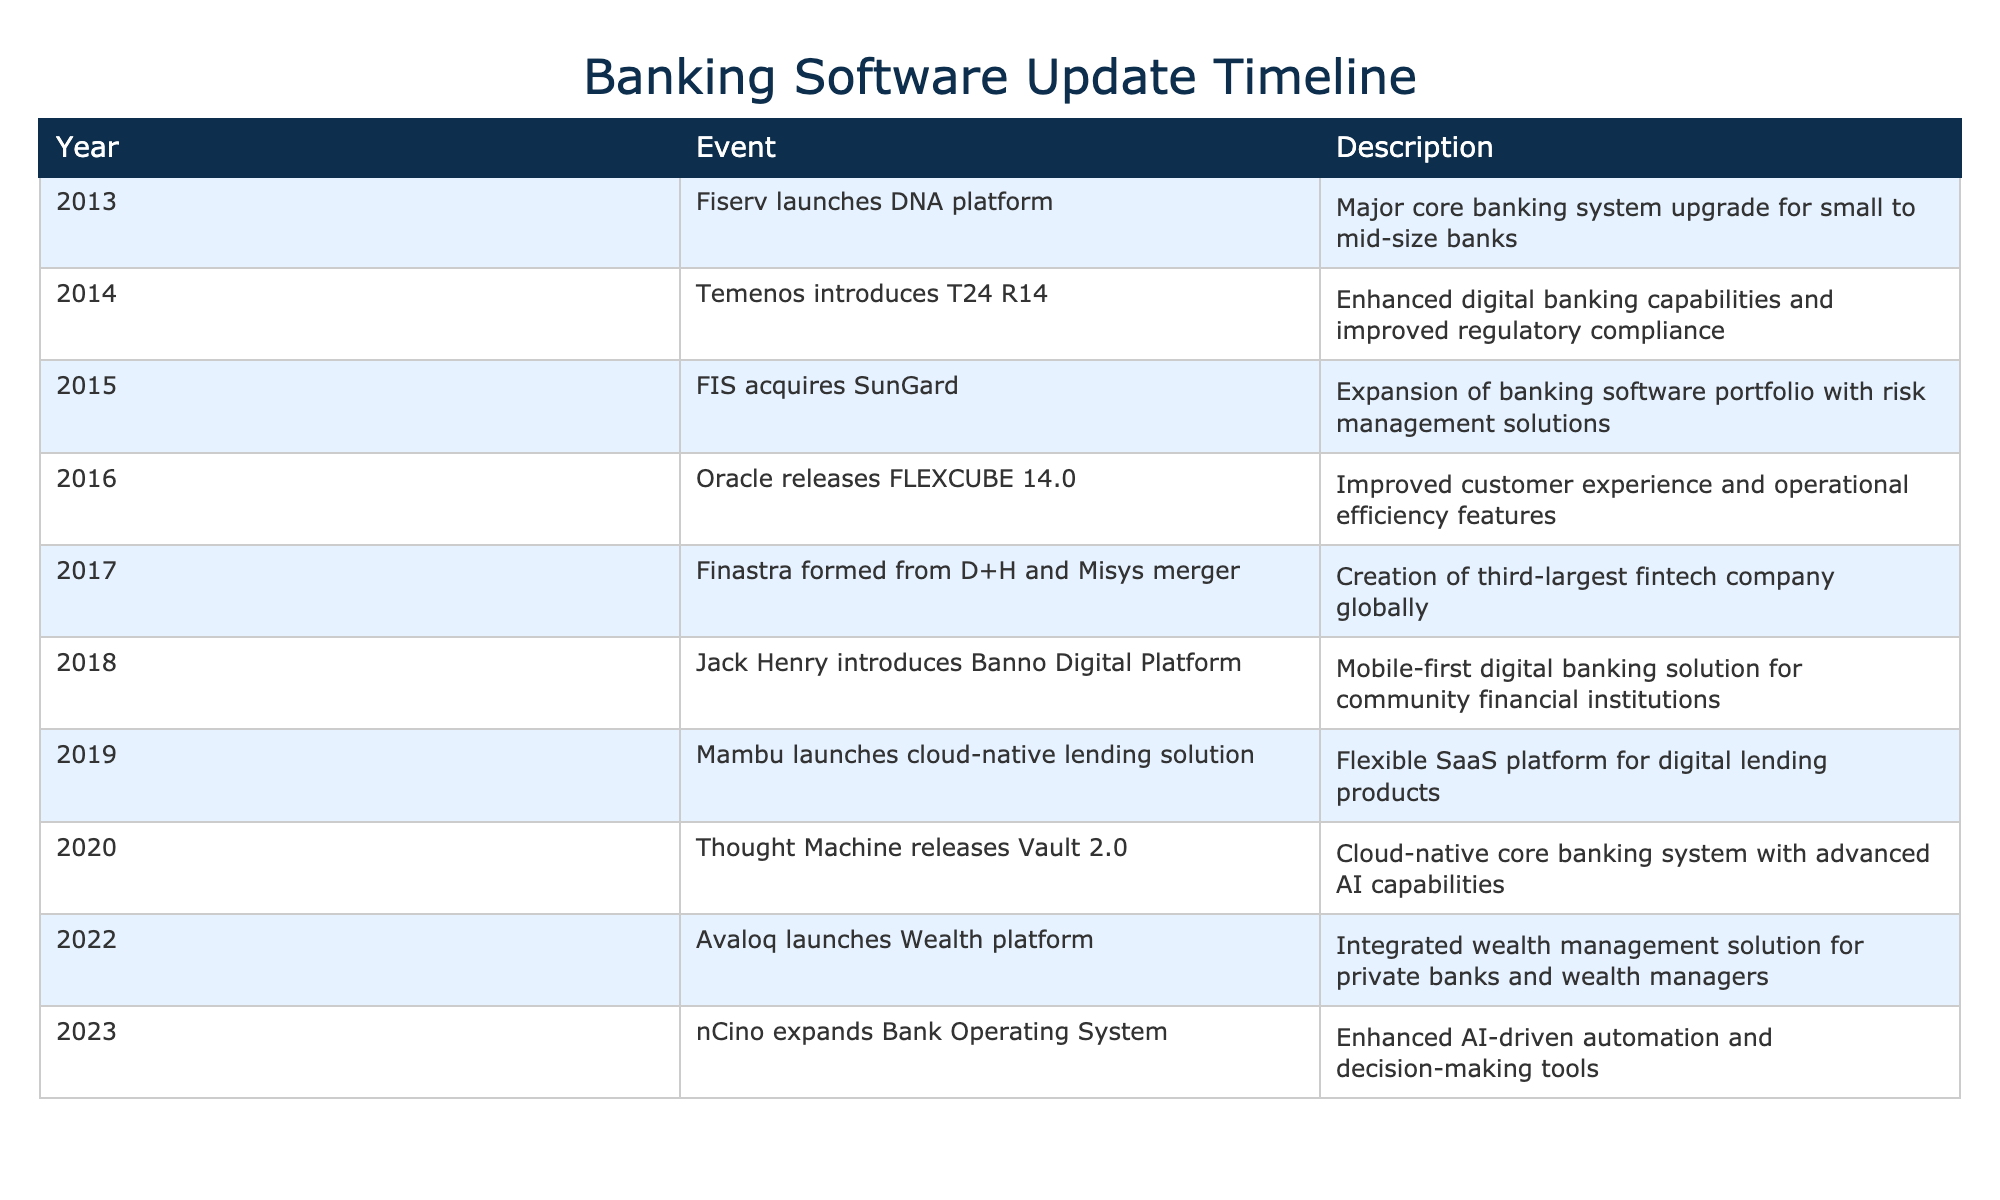What year did Fiserv launch the DNA platform? Fiserv's DNA platform launch is listed under the year 2013 in the table.
Answer: 2013 Which company was formed from the merger of D+H and Misys? The table indicates that Finastra was formed from the merger of D+H and Misys in 2017.
Answer: Finastra True or False: Mambu launched a cloud-native lending solution before 2020. The table shows that Mambu launched their solution in 2019, which is before 2020.
Answer: True What is the difference in years between the introduction of Temenos T24 R14 and the release of Oracle FLEXCUBE 14.0? The introduction of Temenos T24 R14 occurred in 2014 and the release of Oracle FLEXCUBE 14.0 in 2016. Therefore, the difference is 2016 - 2014 = 2 years.
Answer: 2 Which event represents a significant change in the banking software landscape in 2018? The introduction of Jack Henry's Banno Digital Platform in 2018 is a significant development noted in the table, marking a shift towards mobile-first digital solutions.
Answer: Jack Henry Banno Digital Platform 